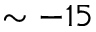Convert formula to latex. <formula><loc_0><loc_0><loc_500><loc_500>\sim - 1 5</formula> 